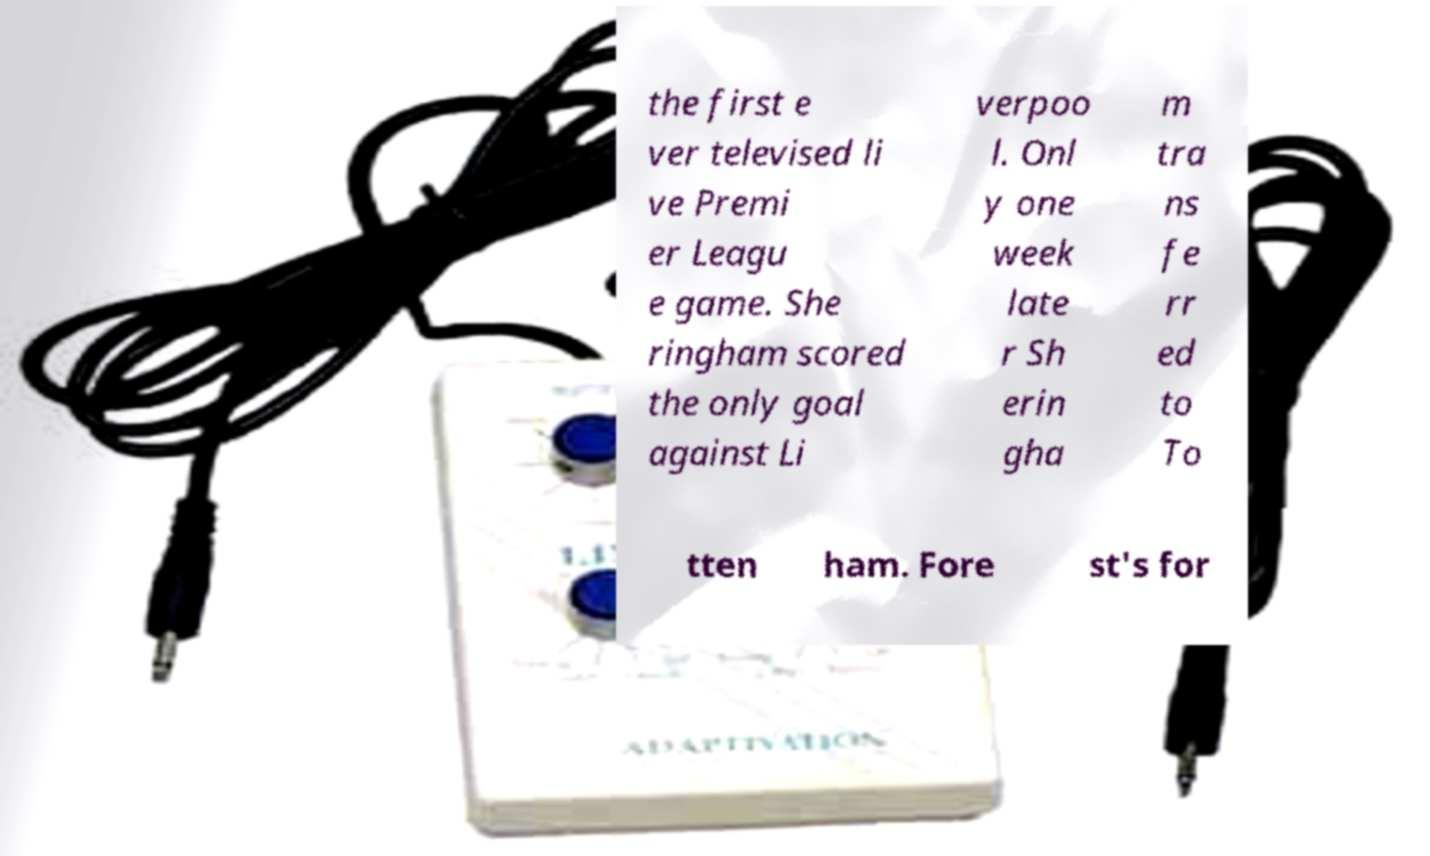Could you extract and type out the text from this image? the first e ver televised li ve Premi er Leagu e game. She ringham scored the only goal against Li verpoo l. Onl y one week late r Sh erin gha m tra ns fe rr ed to To tten ham. Fore st's for 